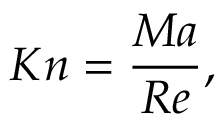<formula> <loc_0><loc_0><loc_500><loc_500>K n = \frac { M a } { R e } ,</formula> 